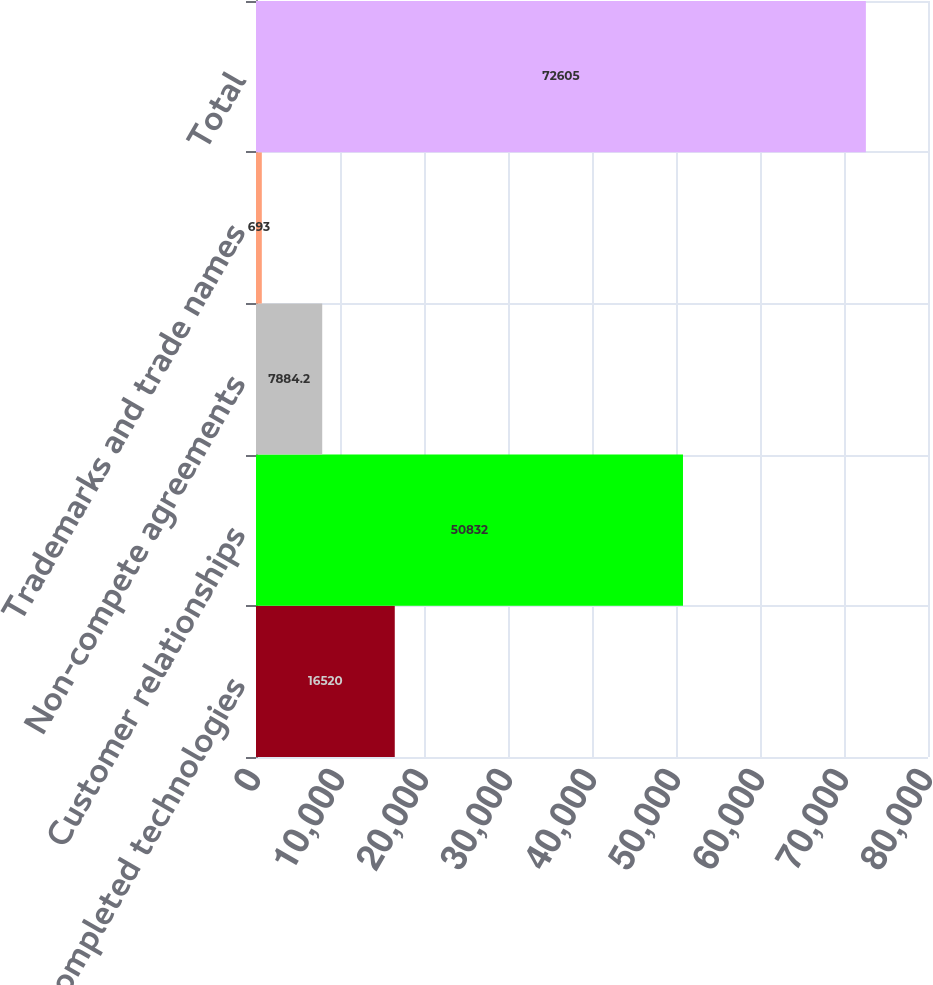<chart> <loc_0><loc_0><loc_500><loc_500><bar_chart><fcel>Completed technologies<fcel>Customer relationships<fcel>Non-compete agreements<fcel>Trademarks and trade names<fcel>Total<nl><fcel>16520<fcel>50832<fcel>7884.2<fcel>693<fcel>72605<nl></chart> 